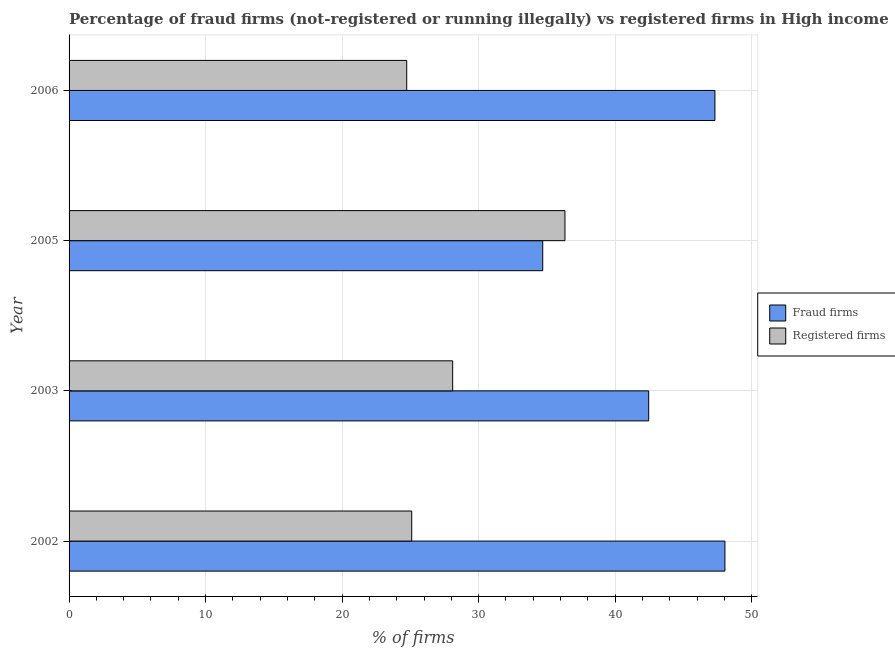How many groups of bars are there?
Your answer should be compact. 4. Are the number of bars on each tick of the Y-axis equal?
Your answer should be very brief. Yes. How many bars are there on the 2nd tick from the top?
Ensure brevity in your answer.  2. How many bars are there on the 2nd tick from the bottom?
Provide a succinct answer. 2. What is the percentage of fraud firms in 2006?
Offer a terse response. 47.31. Across all years, what is the maximum percentage of fraud firms?
Give a very brief answer. 48.04. Across all years, what is the minimum percentage of registered firms?
Offer a very short reply. 24.73. In which year was the percentage of fraud firms minimum?
Provide a succinct answer. 2005. What is the total percentage of fraud firms in the graph?
Your response must be concise. 172.51. What is the difference between the percentage of registered firms in 2003 and that in 2006?
Offer a terse response. 3.37. What is the difference between the percentage of fraud firms in 2003 and the percentage of registered firms in 2006?
Keep it short and to the point. 17.73. What is the average percentage of registered firms per year?
Offer a terse response. 28.57. In the year 2002, what is the difference between the percentage of fraud firms and percentage of registered firms?
Offer a very short reply. 22.94. What is the ratio of the percentage of registered firms in 2002 to that in 2003?
Provide a short and direct response. 0.89. What is the difference between the highest and the second highest percentage of fraud firms?
Offer a very short reply. 0.73. What is the difference between the highest and the lowest percentage of registered firms?
Your answer should be very brief. 11.59. Is the sum of the percentage of fraud firms in 2002 and 2005 greater than the maximum percentage of registered firms across all years?
Ensure brevity in your answer.  Yes. What does the 2nd bar from the top in 2002 represents?
Ensure brevity in your answer.  Fraud firms. What does the 2nd bar from the bottom in 2002 represents?
Provide a succinct answer. Registered firms. How many bars are there?
Make the answer very short. 8. Are all the bars in the graph horizontal?
Offer a very short reply. Yes. How many years are there in the graph?
Keep it short and to the point. 4. What is the difference between two consecutive major ticks on the X-axis?
Ensure brevity in your answer.  10. Does the graph contain grids?
Provide a short and direct response. Yes. How are the legend labels stacked?
Keep it short and to the point. Vertical. What is the title of the graph?
Keep it short and to the point. Percentage of fraud firms (not-registered or running illegally) vs registered firms in High income. What is the label or title of the X-axis?
Provide a succinct answer. % of firms. What is the label or title of the Y-axis?
Ensure brevity in your answer.  Year. What is the % of firms in Fraud firms in 2002?
Provide a short and direct response. 48.04. What is the % of firms of Registered firms in 2002?
Your answer should be compact. 25.1. What is the % of firms in Fraud firms in 2003?
Provide a succinct answer. 42.46. What is the % of firms of Registered firms in 2003?
Offer a terse response. 28.1. What is the % of firms of Fraud firms in 2005?
Make the answer very short. 34.7. What is the % of firms of Registered firms in 2005?
Keep it short and to the point. 36.33. What is the % of firms in Fraud firms in 2006?
Keep it short and to the point. 47.31. What is the % of firms in Registered firms in 2006?
Make the answer very short. 24.73. Across all years, what is the maximum % of firms of Fraud firms?
Give a very brief answer. 48.04. Across all years, what is the maximum % of firms in Registered firms?
Your answer should be compact. 36.33. Across all years, what is the minimum % of firms of Fraud firms?
Your answer should be very brief. 34.7. Across all years, what is the minimum % of firms in Registered firms?
Offer a terse response. 24.73. What is the total % of firms of Fraud firms in the graph?
Your answer should be compact. 172.51. What is the total % of firms in Registered firms in the graph?
Keep it short and to the point. 114.26. What is the difference between the % of firms in Fraud firms in 2002 and that in 2003?
Ensure brevity in your answer.  5.58. What is the difference between the % of firms in Registered firms in 2002 and that in 2003?
Your answer should be very brief. -3. What is the difference between the % of firms of Fraud firms in 2002 and that in 2005?
Make the answer very short. 13.35. What is the difference between the % of firms of Registered firms in 2002 and that in 2005?
Ensure brevity in your answer.  -11.22. What is the difference between the % of firms of Fraud firms in 2002 and that in 2006?
Give a very brief answer. 0.73. What is the difference between the % of firms in Registered firms in 2002 and that in 2006?
Offer a terse response. 0.37. What is the difference between the % of firms of Fraud firms in 2003 and that in 2005?
Offer a terse response. 7.76. What is the difference between the % of firms in Registered firms in 2003 and that in 2005?
Offer a very short reply. -8.22. What is the difference between the % of firms in Fraud firms in 2003 and that in 2006?
Offer a terse response. -4.85. What is the difference between the % of firms in Registered firms in 2003 and that in 2006?
Ensure brevity in your answer.  3.37. What is the difference between the % of firms in Fraud firms in 2005 and that in 2006?
Your answer should be compact. -12.61. What is the difference between the % of firms in Registered firms in 2005 and that in 2006?
Your response must be concise. 11.59. What is the difference between the % of firms of Fraud firms in 2002 and the % of firms of Registered firms in 2003?
Ensure brevity in your answer.  19.94. What is the difference between the % of firms of Fraud firms in 2002 and the % of firms of Registered firms in 2005?
Ensure brevity in your answer.  11.72. What is the difference between the % of firms in Fraud firms in 2002 and the % of firms in Registered firms in 2006?
Provide a succinct answer. 23.31. What is the difference between the % of firms in Fraud firms in 2003 and the % of firms in Registered firms in 2005?
Your answer should be compact. 6.13. What is the difference between the % of firms of Fraud firms in 2003 and the % of firms of Registered firms in 2006?
Provide a short and direct response. 17.73. What is the difference between the % of firms of Fraud firms in 2005 and the % of firms of Registered firms in 2006?
Provide a short and direct response. 9.96. What is the average % of firms in Fraud firms per year?
Keep it short and to the point. 43.13. What is the average % of firms of Registered firms per year?
Provide a succinct answer. 28.56. In the year 2002, what is the difference between the % of firms in Fraud firms and % of firms in Registered firms?
Make the answer very short. 22.94. In the year 2003, what is the difference between the % of firms of Fraud firms and % of firms of Registered firms?
Give a very brief answer. 14.36. In the year 2005, what is the difference between the % of firms in Fraud firms and % of firms in Registered firms?
Provide a succinct answer. -1.63. In the year 2006, what is the difference between the % of firms of Fraud firms and % of firms of Registered firms?
Your answer should be compact. 22.58. What is the ratio of the % of firms of Fraud firms in 2002 to that in 2003?
Offer a terse response. 1.13. What is the ratio of the % of firms of Registered firms in 2002 to that in 2003?
Offer a very short reply. 0.89. What is the ratio of the % of firms of Fraud firms in 2002 to that in 2005?
Make the answer very short. 1.38. What is the ratio of the % of firms in Registered firms in 2002 to that in 2005?
Keep it short and to the point. 0.69. What is the ratio of the % of firms of Fraud firms in 2002 to that in 2006?
Your response must be concise. 1.02. What is the ratio of the % of firms in Registered firms in 2002 to that in 2006?
Your answer should be compact. 1.01. What is the ratio of the % of firms of Fraud firms in 2003 to that in 2005?
Ensure brevity in your answer.  1.22. What is the ratio of the % of firms in Registered firms in 2003 to that in 2005?
Your response must be concise. 0.77. What is the ratio of the % of firms of Fraud firms in 2003 to that in 2006?
Make the answer very short. 0.9. What is the ratio of the % of firms of Registered firms in 2003 to that in 2006?
Make the answer very short. 1.14. What is the ratio of the % of firms of Fraud firms in 2005 to that in 2006?
Your answer should be very brief. 0.73. What is the ratio of the % of firms in Registered firms in 2005 to that in 2006?
Keep it short and to the point. 1.47. What is the difference between the highest and the second highest % of firms of Fraud firms?
Offer a very short reply. 0.73. What is the difference between the highest and the second highest % of firms in Registered firms?
Make the answer very short. 8.22. What is the difference between the highest and the lowest % of firms of Fraud firms?
Keep it short and to the point. 13.35. What is the difference between the highest and the lowest % of firms of Registered firms?
Give a very brief answer. 11.59. 